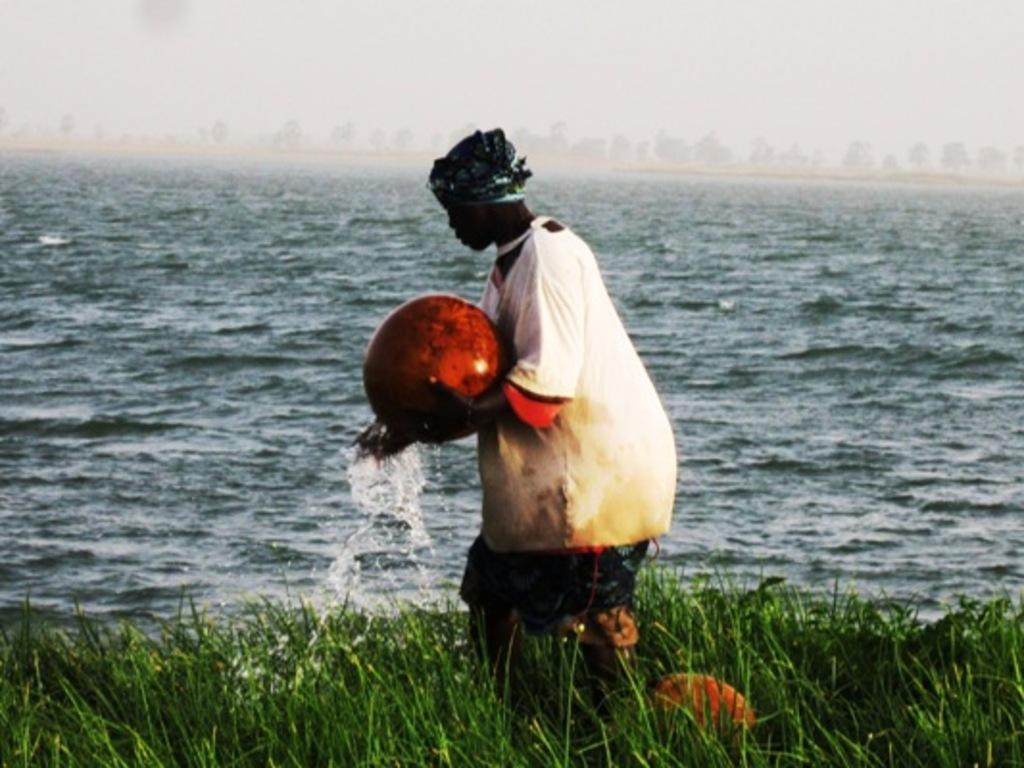What is the person in the image holding? There is a person holding an object in the image. What type of natural environment is visible in the image? There is grass, water, and trees visible in the image. What part of the sky can be seen in the image? The sky is visible in the image. What decision did the person make in the morning before the image was taken? There is no information about the person's morning or any decisions they made before the image was taken. 